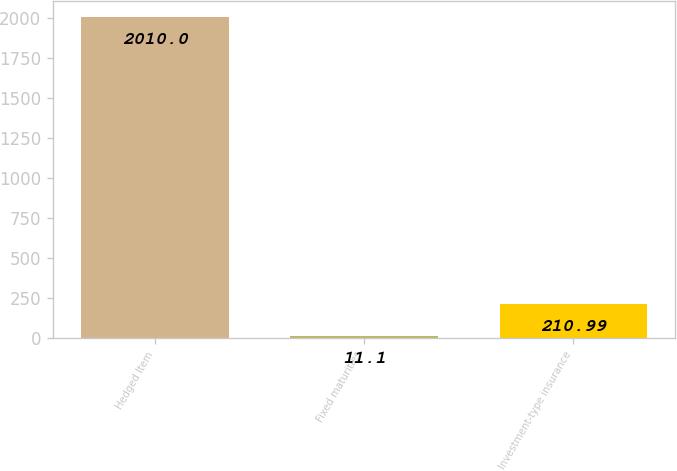Convert chart. <chart><loc_0><loc_0><loc_500><loc_500><bar_chart><fcel>Hedged Item<fcel>Fixed maturities<fcel>Investment-type insurance<nl><fcel>2010<fcel>11.1<fcel>210.99<nl></chart> 